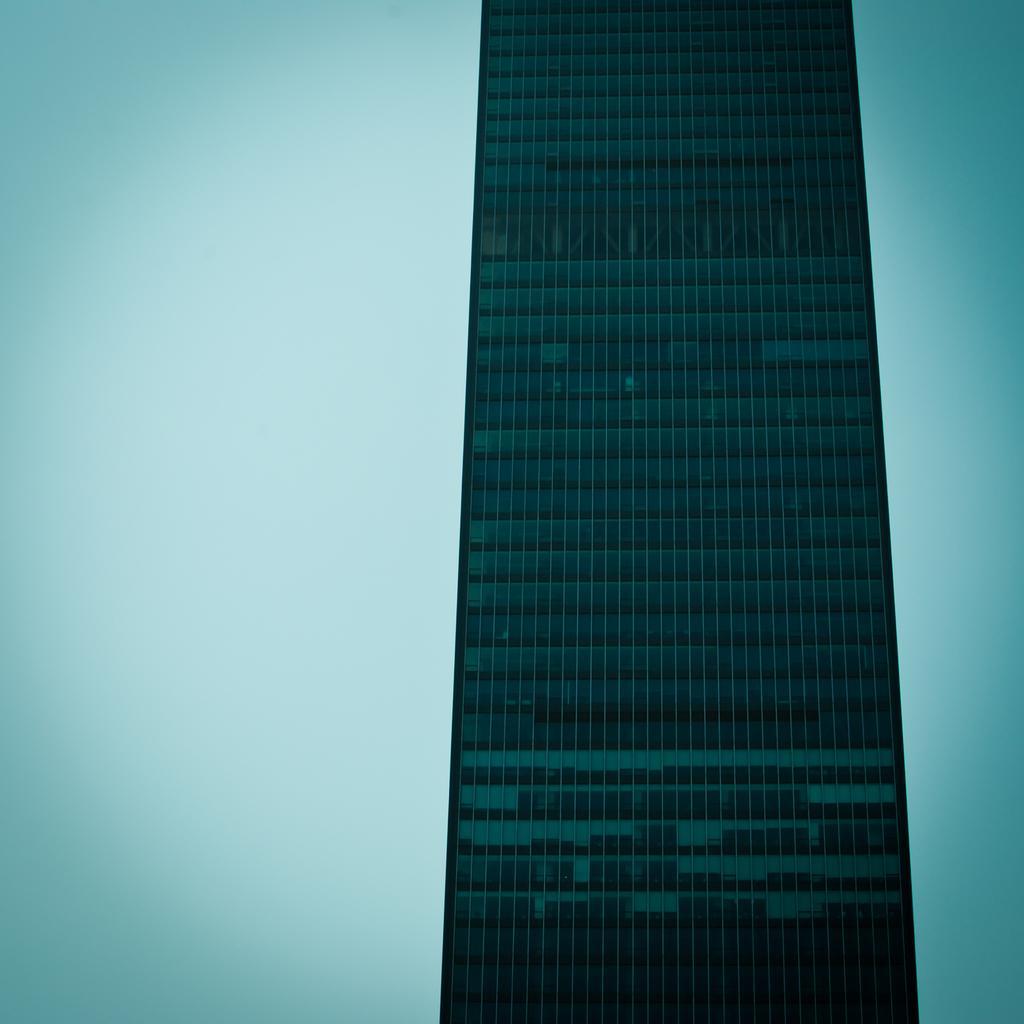Can you describe this image briefly? In this image there is a building. 